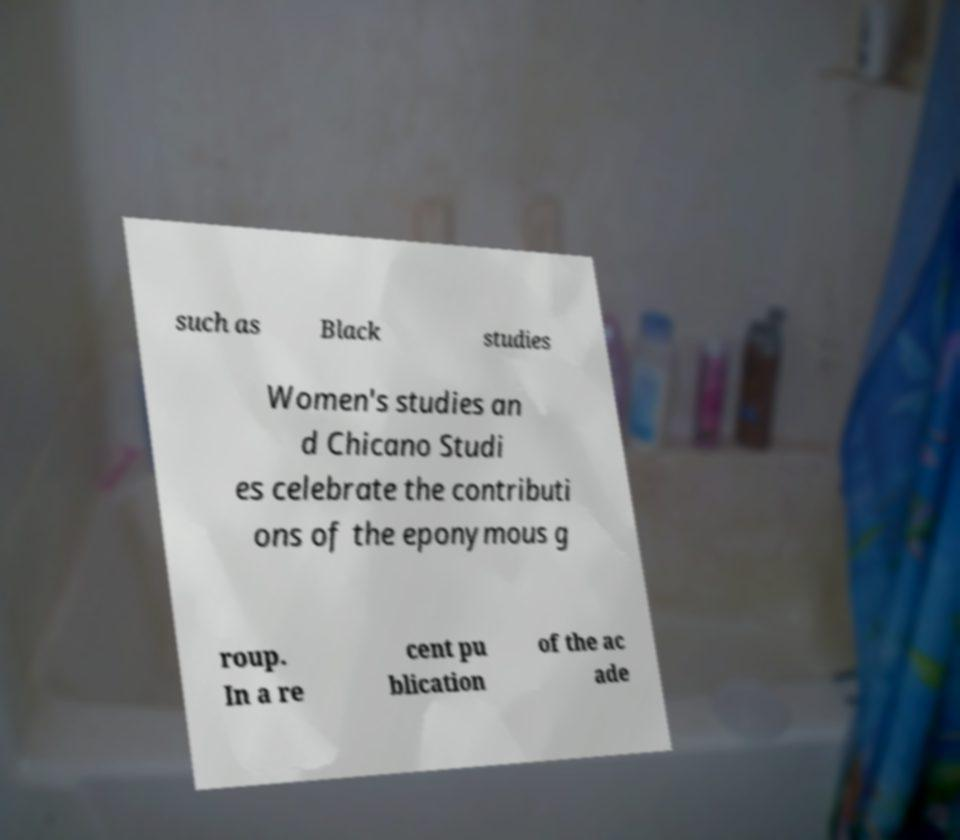Please read and relay the text visible in this image. What does it say? such as Black studies Women's studies an d Chicano Studi es celebrate the contributi ons of the eponymous g roup. In a re cent pu blication of the ac ade 